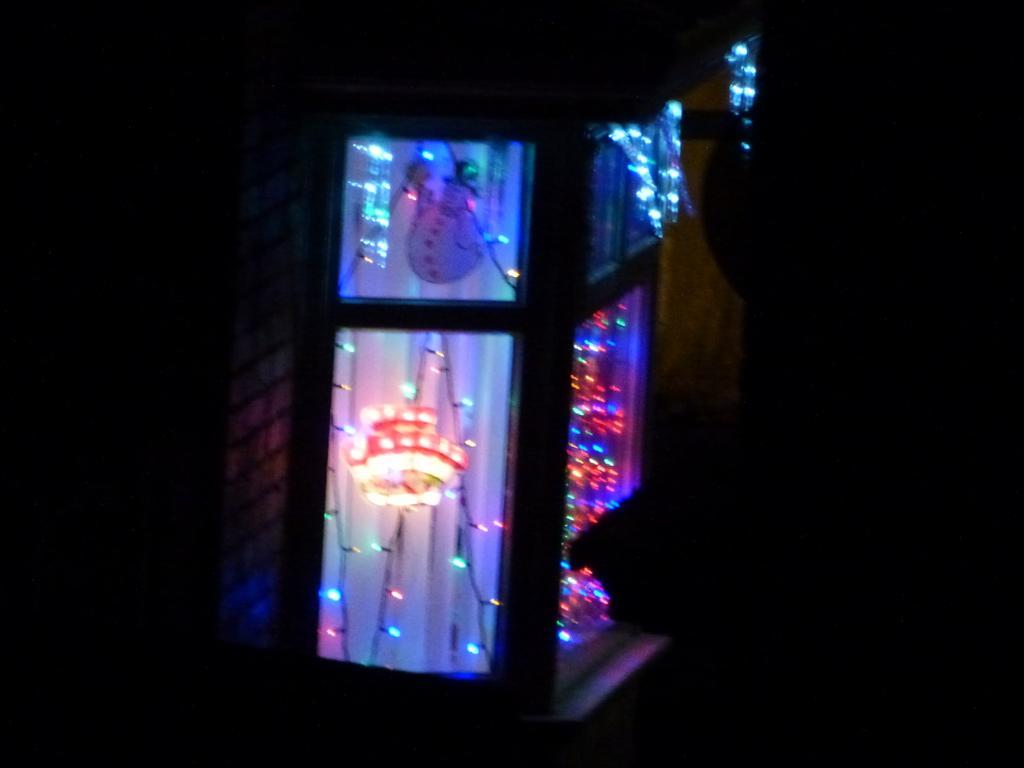Could you give a brief overview of what you see in this image? In this image we can see a window. Behind the window Christmas lights are present. 